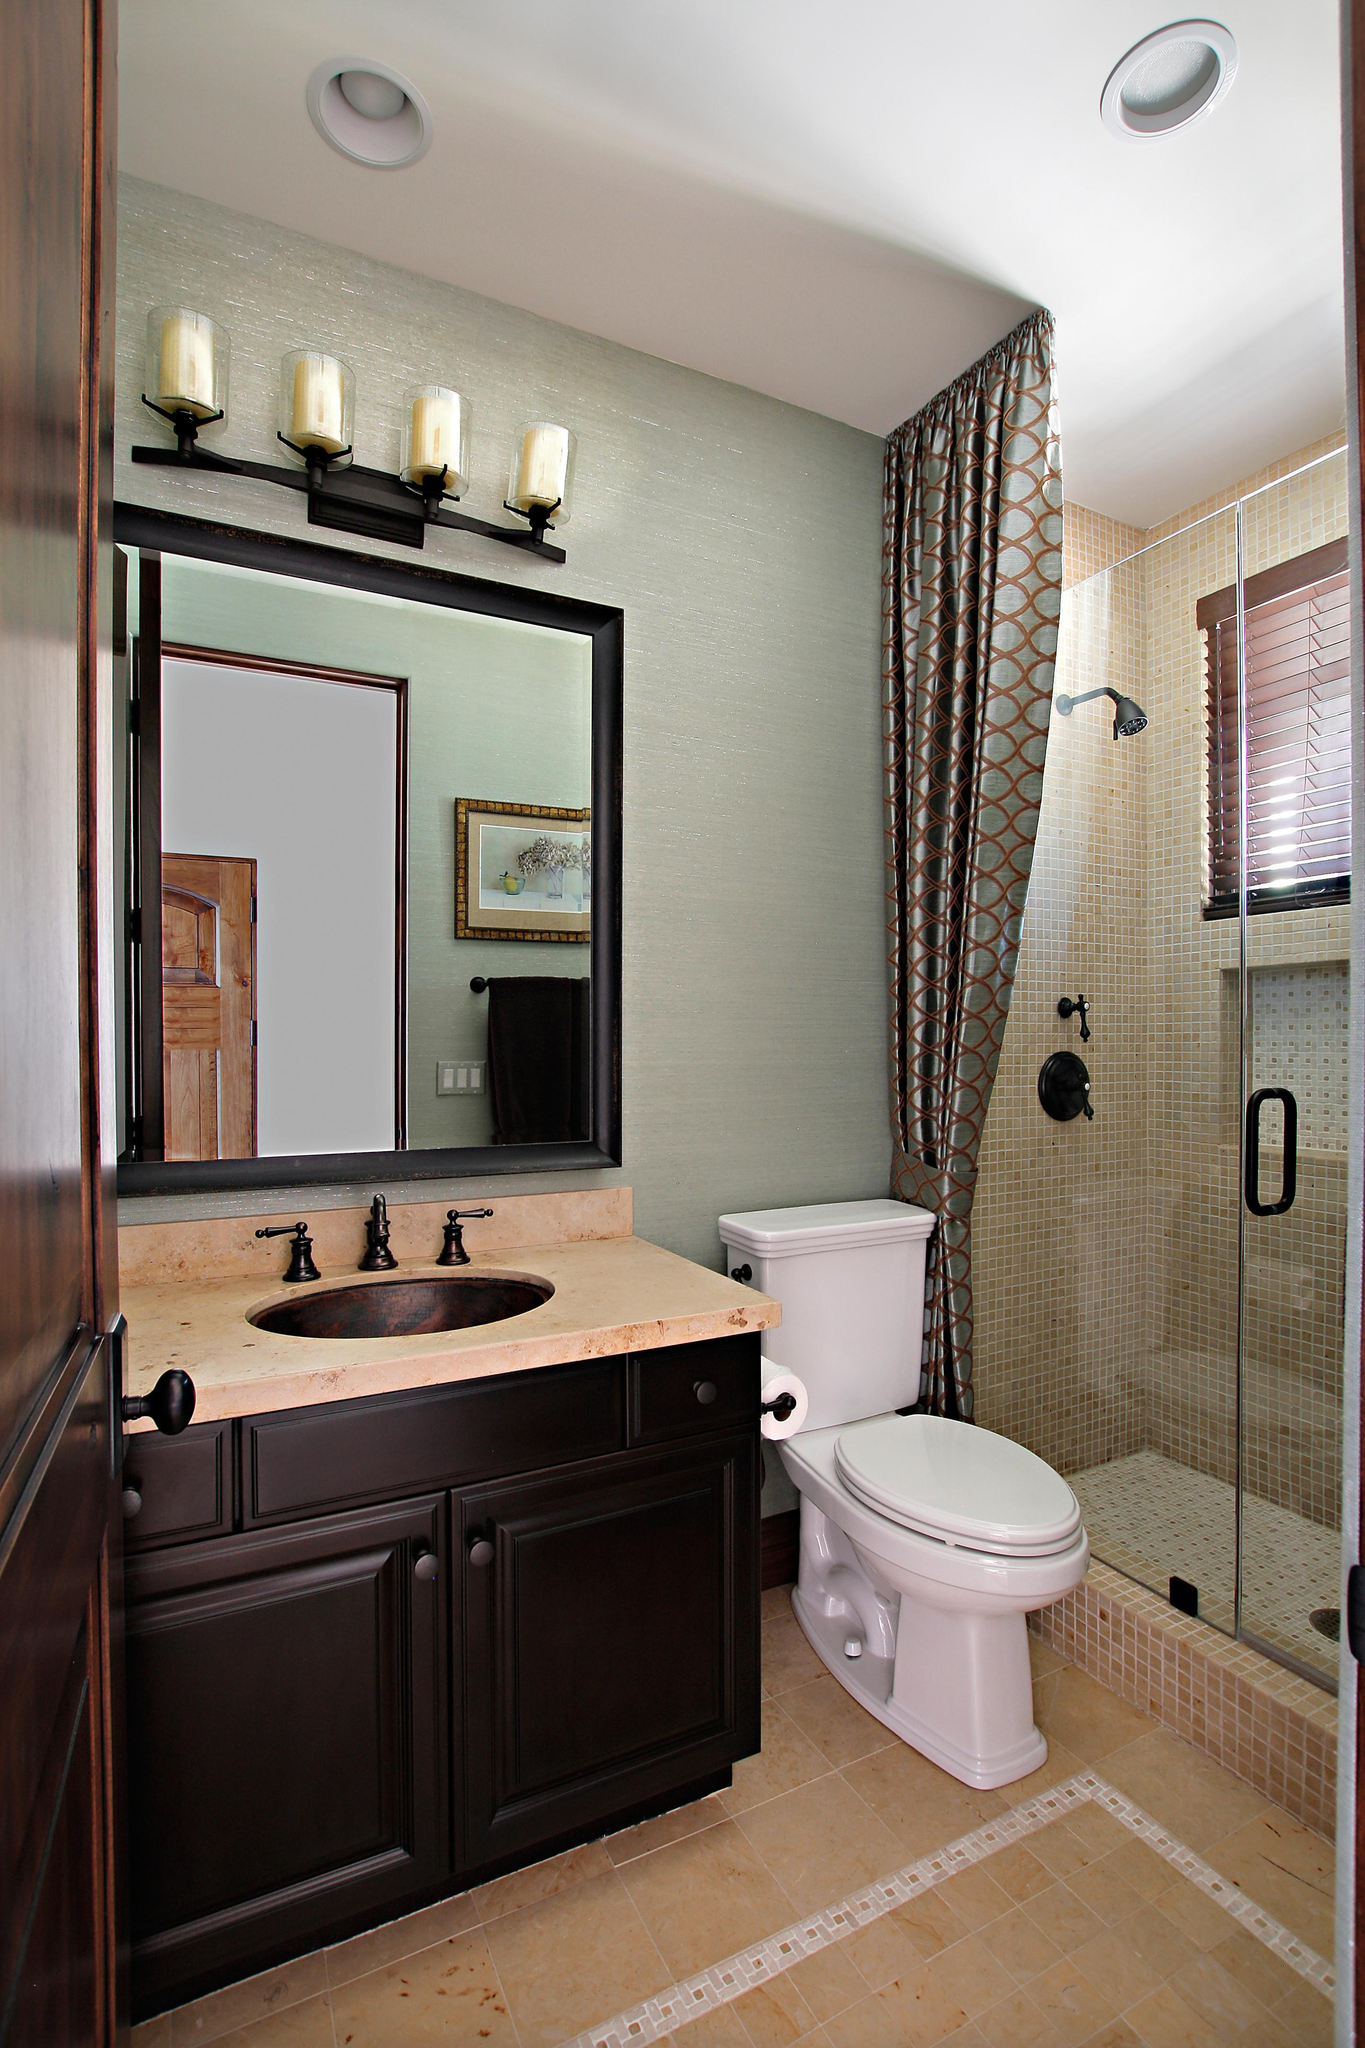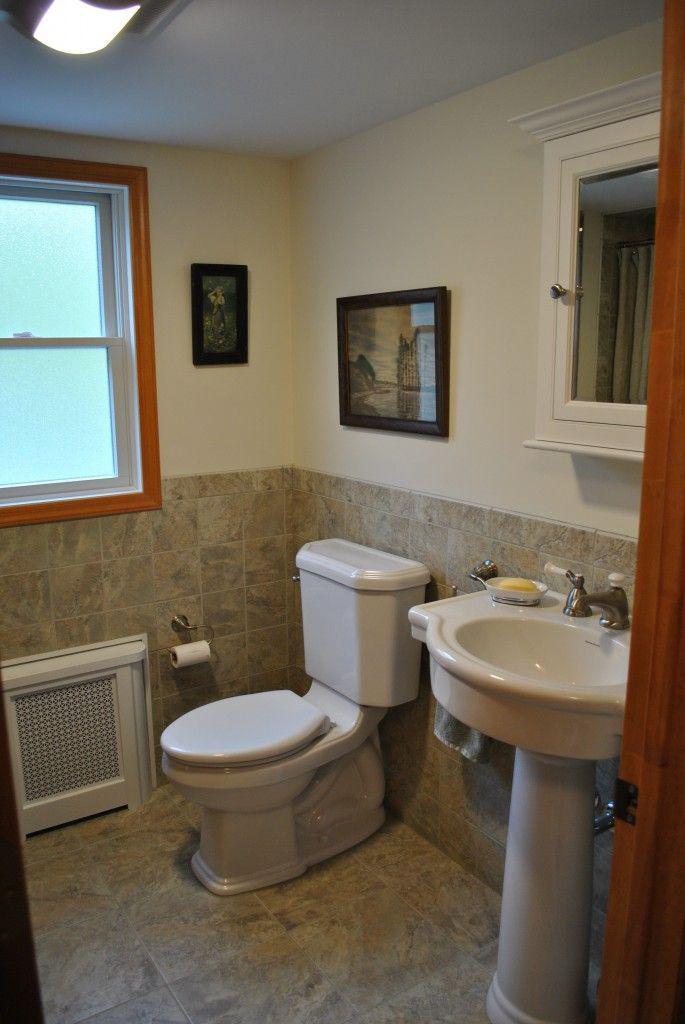The first image is the image on the left, the second image is the image on the right. Assess this claim about the two images: "In one image, a shower stall is on the far end of a bathroom that also features a light colored vanity with one drawer and two doors.". Correct or not? Answer yes or no. No. The first image is the image on the left, the second image is the image on the right. Evaluate the accuracy of this statement regarding the images: "The left image shows a dark vanity with a lighter countertop containing one inset sink with a faucet that is not wall-mounted, next to a traditional toilet with a tank.". Is it true? Answer yes or no. Yes. 